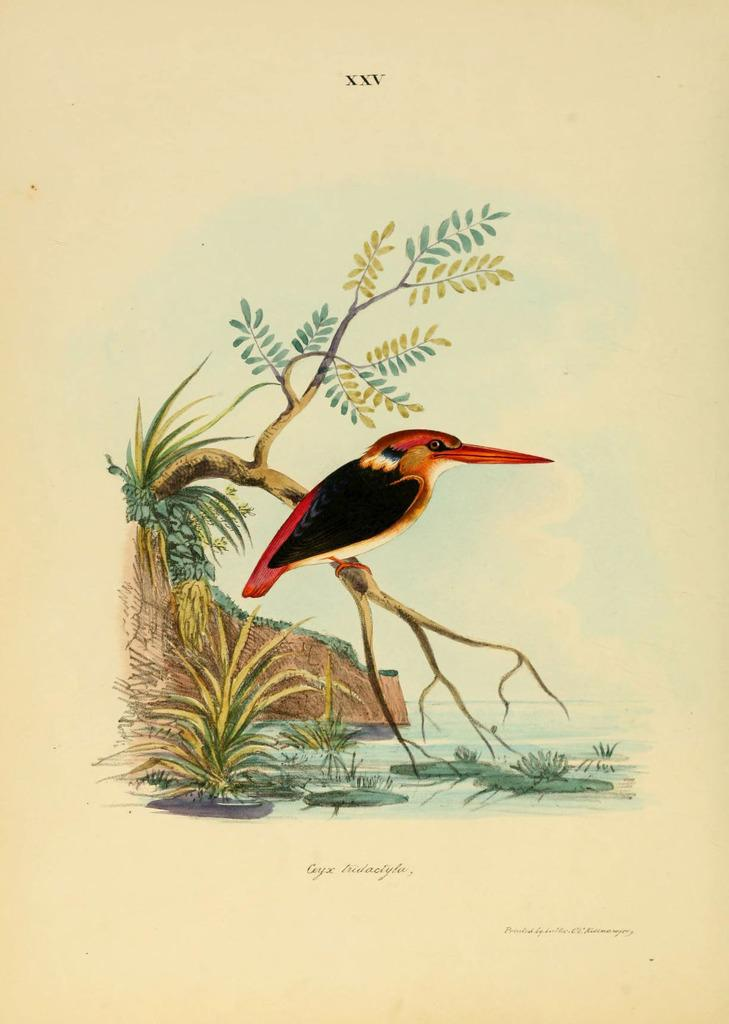What type of animal can be seen in the image? There is a bird in the image. Where is the bird located? The bird is on a branch. What can be seen in the background of the image? There is water, plants, and the sky visible in the image. Are there any dolls or slaves visible in the image? No, there are no dolls or slaves present in the image. Can you see a squirrel in the image? No, there is no squirrel visible in the image; it features a bird on a branch. 